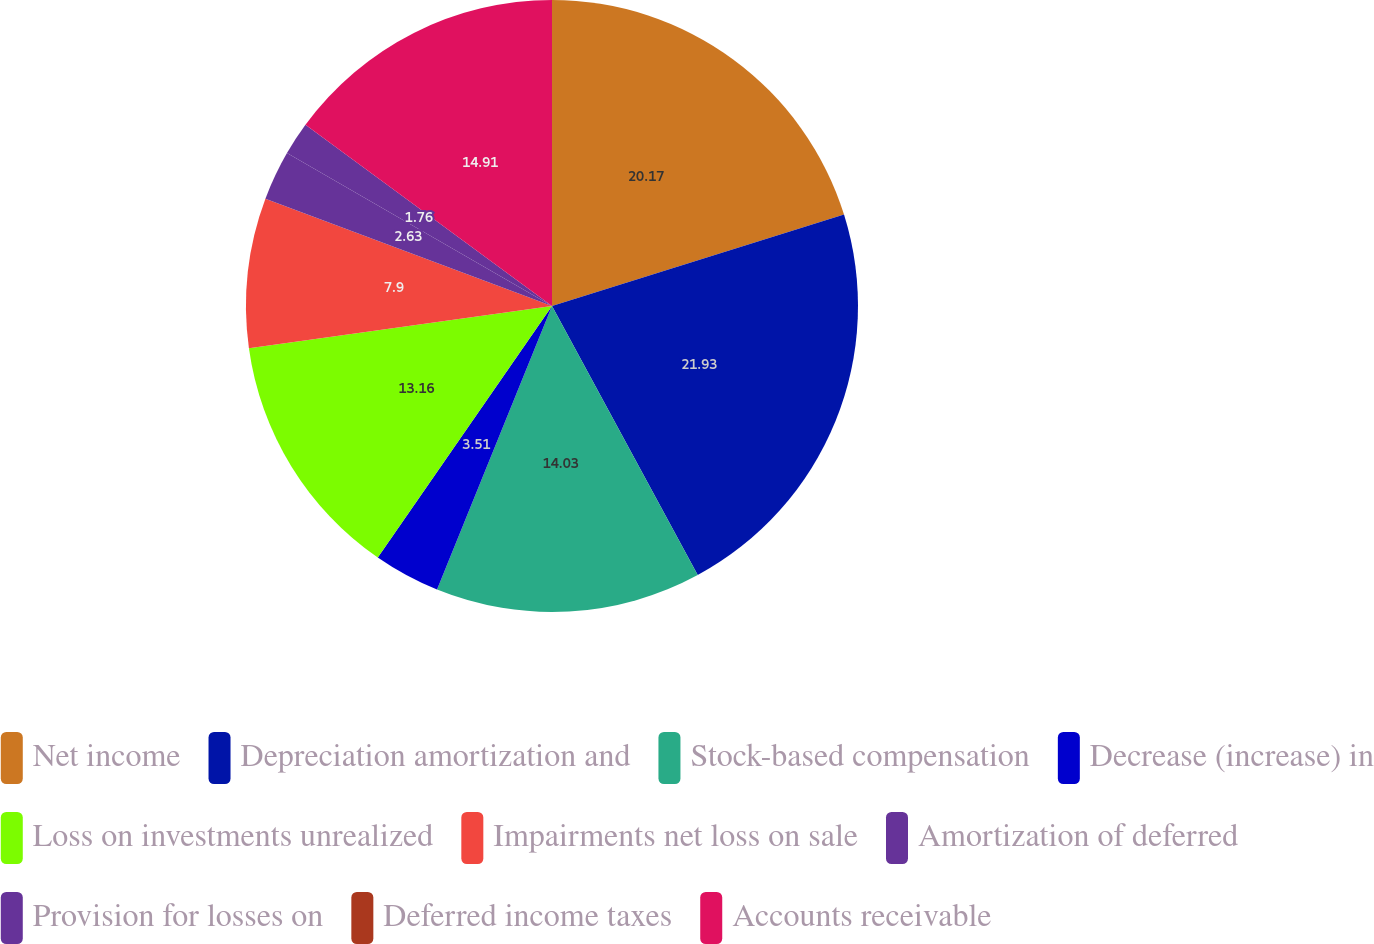<chart> <loc_0><loc_0><loc_500><loc_500><pie_chart><fcel>Net income<fcel>Depreciation amortization and<fcel>Stock-based compensation<fcel>Decrease (increase) in<fcel>Loss on investments unrealized<fcel>Impairments net loss on sale<fcel>Amortization of deferred<fcel>Provision for losses on<fcel>Deferred income taxes<fcel>Accounts receivable<nl><fcel>20.17%<fcel>21.93%<fcel>14.03%<fcel>3.51%<fcel>13.16%<fcel>7.9%<fcel>2.63%<fcel>1.76%<fcel>0.0%<fcel>14.91%<nl></chart> 